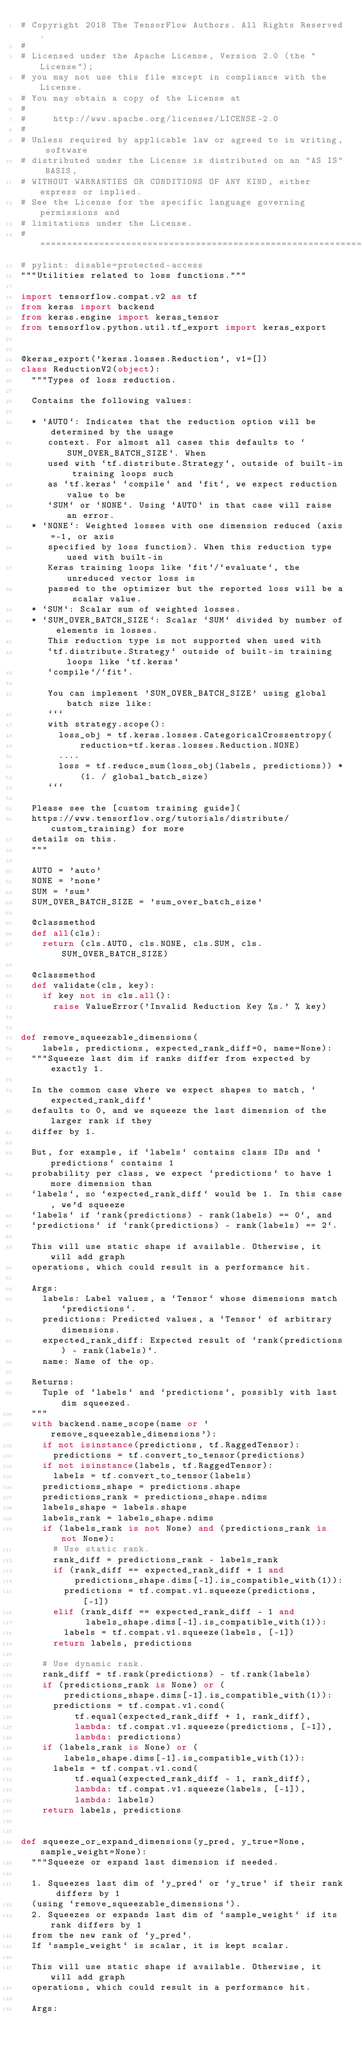<code> <loc_0><loc_0><loc_500><loc_500><_Python_># Copyright 2018 The TensorFlow Authors. All Rights Reserved.
#
# Licensed under the Apache License, Version 2.0 (the "License");
# you may not use this file except in compliance with the License.
# You may obtain a copy of the License at
#
#     http://www.apache.org/licenses/LICENSE-2.0
#
# Unless required by applicable law or agreed to in writing, software
# distributed under the License is distributed on an "AS IS" BASIS,
# WITHOUT WARRANTIES OR CONDITIONS OF ANY KIND, either express or implied.
# See the License for the specific language governing permissions and
# limitations under the License.
# ==============================================================================
# pylint: disable=protected-access
"""Utilities related to loss functions."""

import tensorflow.compat.v2 as tf
from keras import backend
from keras.engine import keras_tensor
from tensorflow.python.util.tf_export import keras_export


@keras_export('keras.losses.Reduction', v1=[])
class ReductionV2(object):
  """Types of loss reduction.

  Contains the following values:

  * `AUTO`: Indicates that the reduction option will be determined by the usage
     context. For almost all cases this defaults to `SUM_OVER_BATCH_SIZE`. When
     used with `tf.distribute.Strategy`, outside of built-in training loops such
     as `tf.keras` `compile` and `fit`, we expect reduction value to be
     `SUM` or `NONE`. Using `AUTO` in that case will raise an error.
  * `NONE`: Weighted losses with one dimension reduced (axis=-1, or axis
     specified by loss function). When this reduction type used with built-in
     Keras training loops like `fit`/`evaluate`, the unreduced vector loss is
     passed to the optimizer but the reported loss will be a scalar value.
  * `SUM`: Scalar sum of weighted losses.
  * `SUM_OVER_BATCH_SIZE`: Scalar `SUM` divided by number of elements in losses.
     This reduction type is not supported when used with
     `tf.distribute.Strategy` outside of built-in training loops like `tf.keras`
     `compile`/`fit`.

     You can implement 'SUM_OVER_BATCH_SIZE' using global batch size like:
     ```
     with strategy.scope():
       loss_obj = tf.keras.losses.CategoricalCrossentropy(
           reduction=tf.keras.losses.Reduction.NONE)
       ....
       loss = tf.reduce_sum(loss_obj(labels, predictions)) *
           (1. / global_batch_size)
     ```

  Please see the [custom training guide](
  https://www.tensorflow.org/tutorials/distribute/custom_training) for more
  details on this.
  """

  AUTO = 'auto'
  NONE = 'none'
  SUM = 'sum'
  SUM_OVER_BATCH_SIZE = 'sum_over_batch_size'

  @classmethod
  def all(cls):
    return (cls.AUTO, cls.NONE, cls.SUM, cls.SUM_OVER_BATCH_SIZE)

  @classmethod
  def validate(cls, key):
    if key not in cls.all():
      raise ValueError('Invalid Reduction Key %s.' % key)


def remove_squeezable_dimensions(
    labels, predictions, expected_rank_diff=0, name=None):
  """Squeeze last dim if ranks differ from expected by exactly 1.

  In the common case where we expect shapes to match, `expected_rank_diff`
  defaults to 0, and we squeeze the last dimension of the larger rank if they
  differ by 1.

  But, for example, if `labels` contains class IDs and `predictions` contains 1
  probability per class, we expect `predictions` to have 1 more dimension than
  `labels`, so `expected_rank_diff` would be 1. In this case, we'd squeeze
  `labels` if `rank(predictions) - rank(labels) == 0`, and
  `predictions` if `rank(predictions) - rank(labels) == 2`.

  This will use static shape if available. Otherwise, it will add graph
  operations, which could result in a performance hit.

  Args:
    labels: Label values, a `Tensor` whose dimensions match `predictions`.
    predictions: Predicted values, a `Tensor` of arbitrary dimensions.
    expected_rank_diff: Expected result of `rank(predictions) - rank(labels)`.
    name: Name of the op.

  Returns:
    Tuple of `labels` and `predictions`, possibly with last dim squeezed.
  """
  with backend.name_scope(name or 'remove_squeezable_dimensions'):
    if not isinstance(predictions, tf.RaggedTensor):
      predictions = tf.convert_to_tensor(predictions)
    if not isinstance(labels, tf.RaggedTensor):
      labels = tf.convert_to_tensor(labels)
    predictions_shape = predictions.shape
    predictions_rank = predictions_shape.ndims
    labels_shape = labels.shape
    labels_rank = labels_shape.ndims
    if (labels_rank is not None) and (predictions_rank is not None):
      # Use static rank.
      rank_diff = predictions_rank - labels_rank
      if (rank_diff == expected_rank_diff + 1 and
          predictions_shape.dims[-1].is_compatible_with(1)):
        predictions = tf.compat.v1.squeeze(predictions, [-1])
      elif (rank_diff == expected_rank_diff - 1 and
            labels_shape.dims[-1].is_compatible_with(1)):
        labels = tf.compat.v1.squeeze(labels, [-1])
      return labels, predictions

    # Use dynamic rank.
    rank_diff = tf.rank(predictions) - tf.rank(labels)
    if (predictions_rank is None) or (
        predictions_shape.dims[-1].is_compatible_with(1)):
      predictions = tf.compat.v1.cond(
          tf.equal(expected_rank_diff + 1, rank_diff),
          lambda: tf.compat.v1.squeeze(predictions, [-1]),
          lambda: predictions)
    if (labels_rank is None) or (
        labels_shape.dims[-1].is_compatible_with(1)):
      labels = tf.compat.v1.cond(
          tf.equal(expected_rank_diff - 1, rank_diff),
          lambda: tf.compat.v1.squeeze(labels, [-1]),
          lambda: labels)
    return labels, predictions


def squeeze_or_expand_dimensions(y_pred, y_true=None, sample_weight=None):
  """Squeeze or expand last dimension if needed.

  1. Squeezes last dim of `y_pred` or `y_true` if their rank differs by 1
  (using `remove_squeezable_dimensions`).
  2. Squeezes or expands last dim of `sample_weight` if its rank differs by 1
  from the new rank of `y_pred`.
  If `sample_weight` is scalar, it is kept scalar.

  This will use static shape if available. Otherwise, it will add graph
  operations, which could result in a performance hit.

  Args:</code> 